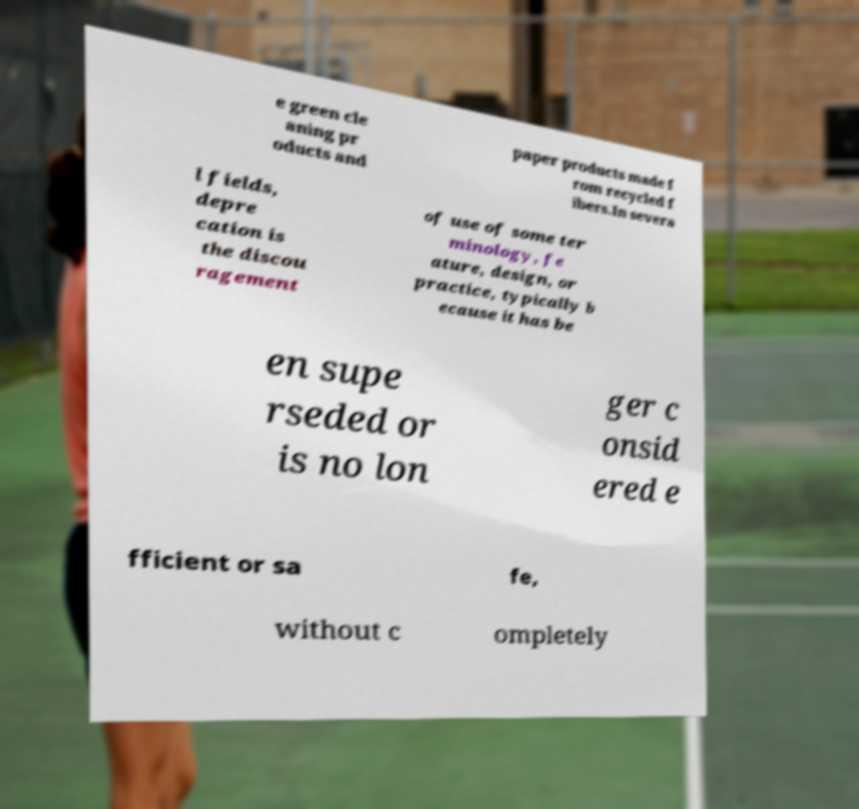What messages or text are displayed in this image? I need them in a readable, typed format. e green cle aning pr oducts and paper products made f rom recycled f ibers.In severa l fields, depre cation is the discou ragement of use of some ter minology, fe ature, design, or practice, typically b ecause it has be en supe rseded or is no lon ger c onsid ered e fficient or sa fe, without c ompletely 